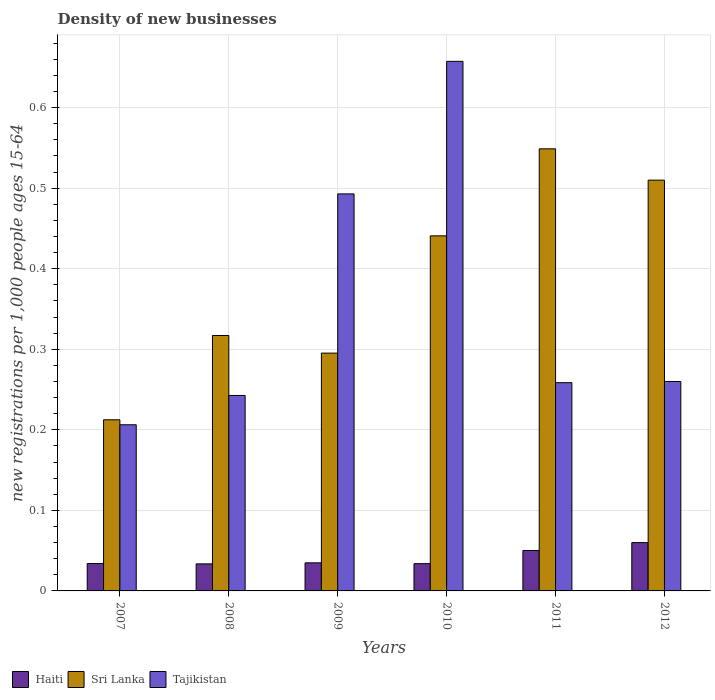Are the number of bars per tick equal to the number of legend labels?
Offer a terse response. Yes. How many bars are there on the 1st tick from the left?
Provide a short and direct response. 3. How many bars are there on the 5th tick from the right?
Offer a very short reply. 3. What is the label of the 2nd group of bars from the left?
Your answer should be compact. 2008. In how many cases, is the number of bars for a given year not equal to the number of legend labels?
Your answer should be very brief. 0. What is the number of new registrations in Sri Lanka in 2012?
Make the answer very short. 0.51. Across all years, what is the maximum number of new registrations in Sri Lanka?
Your response must be concise. 0.55. Across all years, what is the minimum number of new registrations in Haiti?
Provide a short and direct response. 0.03. What is the total number of new registrations in Tajikistan in the graph?
Make the answer very short. 2.12. What is the difference between the number of new registrations in Haiti in 2009 and that in 2011?
Your answer should be very brief. -0.02. What is the difference between the number of new registrations in Tajikistan in 2010 and the number of new registrations in Sri Lanka in 2009?
Provide a succinct answer. 0.36. What is the average number of new registrations in Haiti per year?
Give a very brief answer. 0.04. In the year 2008, what is the difference between the number of new registrations in Sri Lanka and number of new registrations in Tajikistan?
Provide a succinct answer. 0.07. What is the ratio of the number of new registrations in Tajikistan in 2008 to that in 2009?
Provide a succinct answer. 0.49. Is the difference between the number of new registrations in Sri Lanka in 2009 and 2012 greater than the difference between the number of new registrations in Tajikistan in 2009 and 2012?
Keep it short and to the point. No. What is the difference between the highest and the second highest number of new registrations in Tajikistan?
Your answer should be compact. 0.16. What is the difference between the highest and the lowest number of new registrations in Haiti?
Provide a short and direct response. 0.03. Is the sum of the number of new registrations in Haiti in 2009 and 2011 greater than the maximum number of new registrations in Tajikistan across all years?
Your answer should be very brief. No. What does the 2nd bar from the left in 2011 represents?
Ensure brevity in your answer.  Sri Lanka. What does the 1st bar from the right in 2010 represents?
Your answer should be compact. Tajikistan. Is it the case that in every year, the sum of the number of new registrations in Sri Lanka and number of new registrations in Haiti is greater than the number of new registrations in Tajikistan?
Provide a succinct answer. No. Are all the bars in the graph horizontal?
Give a very brief answer. No. What is the difference between two consecutive major ticks on the Y-axis?
Offer a terse response. 0.1. Does the graph contain any zero values?
Keep it short and to the point. No. How many legend labels are there?
Offer a very short reply. 3. What is the title of the graph?
Keep it short and to the point. Density of new businesses. What is the label or title of the Y-axis?
Make the answer very short. New registrations per 1,0 people ages 15-64. What is the new registrations per 1,000 people ages 15-64 of Haiti in 2007?
Keep it short and to the point. 0.03. What is the new registrations per 1,000 people ages 15-64 of Sri Lanka in 2007?
Provide a short and direct response. 0.21. What is the new registrations per 1,000 people ages 15-64 in Tajikistan in 2007?
Your answer should be compact. 0.21. What is the new registrations per 1,000 people ages 15-64 in Haiti in 2008?
Ensure brevity in your answer.  0.03. What is the new registrations per 1,000 people ages 15-64 in Sri Lanka in 2008?
Keep it short and to the point. 0.32. What is the new registrations per 1,000 people ages 15-64 in Tajikistan in 2008?
Offer a very short reply. 0.24. What is the new registrations per 1,000 people ages 15-64 in Haiti in 2009?
Give a very brief answer. 0.03. What is the new registrations per 1,000 people ages 15-64 in Sri Lanka in 2009?
Keep it short and to the point. 0.3. What is the new registrations per 1,000 people ages 15-64 in Tajikistan in 2009?
Provide a short and direct response. 0.49. What is the new registrations per 1,000 people ages 15-64 of Haiti in 2010?
Provide a short and direct response. 0.03. What is the new registrations per 1,000 people ages 15-64 in Sri Lanka in 2010?
Offer a very short reply. 0.44. What is the new registrations per 1,000 people ages 15-64 of Tajikistan in 2010?
Offer a terse response. 0.66. What is the new registrations per 1,000 people ages 15-64 of Haiti in 2011?
Offer a terse response. 0.05. What is the new registrations per 1,000 people ages 15-64 of Sri Lanka in 2011?
Offer a terse response. 0.55. What is the new registrations per 1,000 people ages 15-64 of Tajikistan in 2011?
Your response must be concise. 0.26. What is the new registrations per 1,000 people ages 15-64 of Haiti in 2012?
Offer a terse response. 0.06. What is the new registrations per 1,000 people ages 15-64 in Sri Lanka in 2012?
Your answer should be very brief. 0.51. What is the new registrations per 1,000 people ages 15-64 of Tajikistan in 2012?
Offer a very short reply. 0.26. Across all years, what is the maximum new registrations per 1,000 people ages 15-64 in Sri Lanka?
Offer a terse response. 0.55. Across all years, what is the maximum new registrations per 1,000 people ages 15-64 in Tajikistan?
Your answer should be very brief. 0.66. Across all years, what is the minimum new registrations per 1,000 people ages 15-64 in Haiti?
Your answer should be very brief. 0.03. Across all years, what is the minimum new registrations per 1,000 people ages 15-64 in Sri Lanka?
Your answer should be compact. 0.21. Across all years, what is the minimum new registrations per 1,000 people ages 15-64 in Tajikistan?
Provide a succinct answer. 0.21. What is the total new registrations per 1,000 people ages 15-64 in Haiti in the graph?
Ensure brevity in your answer.  0.25. What is the total new registrations per 1,000 people ages 15-64 of Sri Lanka in the graph?
Make the answer very short. 2.32. What is the total new registrations per 1,000 people ages 15-64 of Tajikistan in the graph?
Your answer should be very brief. 2.12. What is the difference between the new registrations per 1,000 people ages 15-64 in Haiti in 2007 and that in 2008?
Offer a terse response. 0. What is the difference between the new registrations per 1,000 people ages 15-64 in Sri Lanka in 2007 and that in 2008?
Provide a succinct answer. -0.1. What is the difference between the new registrations per 1,000 people ages 15-64 in Tajikistan in 2007 and that in 2008?
Provide a short and direct response. -0.04. What is the difference between the new registrations per 1,000 people ages 15-64 of Haiti in 2007 and that in 2009?
Offer a terse response. -0. What is the difference between the new registrations per 1,000 people ages 15-64 of Sri Lanka in 2007 and that in 2009?
Keep it short and to the point. -0.08. What is the difference between the new registrations per 1,000 people ages 15-64 of Tajikistan in 2007 and that in 2009?
Offer a very short reply. -0.29. What is the difference between the new registrations per 1,000 people ages 15-64 of Haiti in 2007 and that in 2010?
Your answer should be compact. 0. What is the difference between the new registrations per 1,000 people ages 15-64 of Sri Lanka in 2007 and that in 2010?
Offer a very short reply. -0.23. What is the difference between the new registrations per 1,000 people ages 15-64 of Tajikistan in 2007 and that in 2010?
Give a very brief answer. -0.45. What is the difference between the new registrations per 1,000 people ages 15-64 of Haiti in 2007 and that in 2011?
Provide a succinct answer. -0.02. What is the difference between the new registrations per 1,000 people ages 15-64 in Sri Lanka in 2007 and that in 2011?
Your answer should be very brief. -0.34. What is the difference between the new registrations per 1,000 people ages 15-64 in Tajikistan in 2007 and that in 2011?
Your answer should be very brief. -0.05. What is the difference between the new registrations per 1,000 people ages 15-64 in Haiti in 2007 and that in 2012?
Provide a succinct answer. -0.03. What is the difference between the new registrations per 1,000 people ages 15-64 in Sri Lanka in 2007 and that in 2012?
Your answer should be compact. -0.3. What is the difference between the new registrations per 1,000 people ages 15-64 of Tajikistan in 2007 and that in 2012?
Provide a short and direct response. -0.05. What is the difference between the new registrations per 1,000 people ages 15-64 in Haiti in 2008 and that in 2009?
Your response must be concise. -0. What is the difference between the new registrations per 1,000 people ages 15-64 of Sri Lanka in 2008 and that in 2009?
Make the answer very short. 0.02. What is the difference between the new registrations per 1,000 people ages 15-64 of Tajikistan in 2008 and that in 2009?
Make the answer very short. -0.25. What is the difference between the new registrations per 1,000 people ages 15-64 in Haiti in 2008 and that in 2010?
Offer a terse response. -0. What is the difference between the new registrations per 1,000 people ages 15-64 of Sri Lanka in 2008 and that in 2010?
Your answer should be very brief. -0.12. What is the difference between the new registrations per 1,000 people ages 15-64 in Tajikistan in 2008 and that in 2010?
Offer a very short reply. -0.41. What is the difference between the new registrations per 1,000 people ages 15-64 of Haiti in 2008 and that in 2011?
Make the answer very short. -0.02. What is the difference between the new registrations per 1,000 people ages 15-64 of Sri Lanka in 2008 and that in 2011?
Provide a succinct answer. -0.23. What is the difference between the new registrations per 1,000 people ages 15-64 in Tajikistan in 2008 and that in 2011?
Your response must be concise. -0.02. What is the difference between the new registrations per 1,000 people ages 15-64 in Haiti in 2008 and that in 2012?
Provide a succinct answer. -0.03. What is the difference between the new registrations per 1,000 people ages 15-64 in Sri Lanka in 2008 and that in 2012?
Offer a terse response. -0.19. What is the difference between the new registrations per 1,000 people ages 15-64 of Tajikistan in 2008 and that in 2012?
Your answer should be very brief. -0.02. What is the difference between the new registrations per 1,000 people ages 15-64 of Haiti in 2009 and that in 2010?
Your answer should be very brief. 0. What is the difference between the new registrations per 1,000 people ages 15-64 in Sri Lanka in 2009 and that in 2010?
Provide a succinct answer. -0.15. What is the difference between the new registrations per 1,000 people ages 15-64 in Tajikistan in 2009 and that in 2010?
Your answer should be compact. -0.16. What is the difference between the new registrations per 1,000 people ages 15-64 in Haiti in 2009 and that in 2011?
Your answer should be very brief. -0.02. What is the difference between the new registrations per 1,000 people ages 15-64 in Sri Lanka in 2009 and that in 2011?
Your response must be concise. -0.25. What is the difference between the new registrations per 1,000 people ages 15-64 in Tajikistan in 2009 and that in 2011?
Your answer should be compact. 0.23. What is the difference between the new registrations per 1,000 people ages 15-64 in Haiti in 2009 and that in 2012?
Offer a very short reply. -0.03. What is the difference between the new registrations per 1,000 people ages 15-64 in Sri Lanka in 2009 and that in 2012?
Ensure brevity in your answer.  -0.21. What is the difference between the new registrations per 1,000 people ages 15-64 in Tajikistan in 2009 and that in 2012?
Make the answer very short. 0.23. What is the difference between the new registrations per 1,000 people ages 15-64 in Haiti in 2010 and that in 2011?
Ensure brevity in your answer.  -0.02. What is the difference between the new registrations per 1,000 people ages 15-64 in Sri Lanka in 2010 and that in 2011?
Provide a short and direct response. -0.11. What is the difference between the new registrations per 1,000 people ages 15-64 in Tajikistan in 2010 and that in 2011?
Make the answer very short. 0.4. What is the difference between the new registrations per 1,000 people ages 15-64 of Haiti in 2010 and that in 2012?
Provide a short and direct response. -0.03. What is the difference between the new registrations per 1,000 people ages 15-64 of Sri Lanka in 2010 and that in 2012?
Make the answer very short. -0.07. What is the difference between the new registrations per 1,000 people ages 15-64 in Tajikistan in 2010 and that in 2012?
Offer a terse response. 0.4. What is the difference between the new registrations per 1,000 people ages 15-64 of Haiti in 2011 and that in 2012?
Provide a succinct answer. -0.01. What is the difference between the new registrations per 1,000 people ages 15-64 in Sri Lanka in 2011 and that in 2012?
Offer a very short reply. 0.04. What is the difference between the new registrations per 1,000 people ages 15-64 of Tajikistan in 2011 and that in 2012?
Provide a succinct answer. -0. What is the difference between the new registrations per 1,000 people ages 15-64 of Haiti in 2007 and the new registrations per 1,000 people ages 15-64 of Sri Lanka in 2008?
Give a very brief answer. -0.28. What is the difference between the new registrations per 1,000 people ages 15-64 in Haiti in 2007 and the new registrations per 1,000 people ages 15-64 in Tajikistan in 2008?
Ensure brevity in your answer.  -0.21. What is the difference between the new registrations per 1,000 people ages 15-64 in Sri Lanka in 2007 and the new registrations per 1,000 people ages 15-64 in Tajikistan in 2008?
Provide a succinct answer. -0.03. What is the difference between the new registrations per 1,000 people ages 15-64 of Haiti in 2007 and the new registrations per 1,000 people ages 15-64 of Sri Lanka in 2009?
Provide a short and direct response. -0.26. What is the difference between the new registrations per 1,000 people ages 15-64 in Haiti in 2007 and the new registrations per 1,000 people ages 15-64 in Tajikistan in 2009?
Your answer should be compact. -0.46. What is the difference between the new registrations per 1,000 people ages 15-64 in Sri Lanka in 2007 and the new registrations per 1,000 people ages 15-64 in Tajikistan in 2009?
Make the answer very short. -0.28. What is the difference between the new registrations per 1,000 people ages 15-64 of Haiti in 2007 and the new registrations per 1,000 people ages 15-64 of Sri Lanka in 2010?
Provide a succinct answer. -0.41. What is the difference between the new registrations per 1,000 people ages 15-64 in Haiti in 2007 and the new registrations per 1,000 people ages 15-64 in Tajikistan in 2010?
Your answer should be compact. -0.62. What is the difference between the new registrations per 1,000 people ages 15-64 in Sri Lanka in 2007 and the new registrations per 1,000 people ages 15-64 in Tajikistan in 2010?
Make the answer very short. -0.45. What is the difference between the new registrations per 1,000 people ages 15-64 in Haiti in 2007 and the new registrations per 1,000 people ages 15-64 in Sri Lanka in 2011?
Ensure brevity in your answer.  -0.51. What is the difference between the new registrations per 1,000 people ages 15-64 of Haiti in 2007 and the new registrations per 1,000 people ages 15-64 of Tajikistan in 2011?
Provide a succinct answer. -0.22. What is the difference between the new registrations per 1,000 people ages 15-64 in Sri Lanka in 2007 and the new registrations per 1,000 people ages 15-64 in Tajikistan in 2011?
Ensure brevity in your answer.  -0.05. What is the difference between the new registrations per 1,000 people ages 15-64 in Haiti in 2007 and the new registrations per 1,000 people ages 15-64 in Sri Lanka in 2012?
Give a very brief answer. -0.48. What is the difference between the new registrations per 1,000 people ages 15-64 in Haiti in 2007 and the new registrations per 1,000 people ages 15-64 in Tajikistan in 2012?
Offer a very short reply. -0.23. What is the difference between the new registrations per 1,000 people ages 15-64 of Sri Lanka in 2007 and the new registrations per 1,000 people ages 15-64 of Tajikistan in 2012?
Keep it short and to the point. -0.05. What is the difference between the new registrations per 1,000 people ages 15-64 of Haiti in 2008 and the new registrations per 1,000 people ages 15-64 of Sri Lanka in 2009?
Make the answer very short. -0.26. What is the difference between the new registrations per 1,000 people ages 15-64 of Haiti in 2008 and the new registrations per 1,000 people ages 15-64 of Tajikistan in 2009?
Your response must be concise. -0.46. What is the difference between the new registrations per 1,000 people ages 15-64 of Sri Lanka in 2008 and the new registrations per 1,000 people ages 15-64 of Tajikistan in 2009?
Ensure brevity in your answer.  -0.18. What is the difference between the new registrations per 1,000 people ages 15-64 in Haiti in 2008 and the new registrations per 1,000 people ages 15-64 in Sri Lanka in 2010?
Keep it short and to the point. -0.41. What is the difference between the new registrations per 1,000 people ages 15-64 in Haiti in 2008 and the new registrations per 1,000 people ages 15-64 in Tajikistan in 2010?
Ensure brevity in your answer.  -0.62. What is the difference between the new registrations per 1,000 people ages 15-64 of Sri Lanka in 2008 and the new registrations per 1,000 people ages 15-64 of Tajikistan in 2010?
Your response must be concise. -0.34. What is the difference between the new registrations per 1,000 people ages 15-64 in Haiti in 2008 and the new registrations per 1,000 people ages 15-64 in Sri Lanka in 2011?
Ensure brevity in your answer.  -0.52. What is the difference between the new registrations per 1,000 people ages 15-64 of Haiti in 2008 and the new registrations per 1,000 people ages 15-64 of Tajikistan in 2011?
Offer a terse response. -0.23. What is the difference between the new registrations per 1,000 people ages 15-64 in Sri Lanka in 2008 and the new registrations per 1,000 people ages 15-64 in Tajikistan in 2011?
Ensure brevity in your answer.  0.06. What is the difference between the new registrations per 1,000 people ages 15-64 in Haiti in 2008 and the new registrations per 1,000 people ages 15-64 in Sri Lanka in 2012?
Make the answer very short. -0.48. What is the difference between the new registrations per 1,000 people ages 15-64 of Haiti in 2008 and the new registrations per 1,000 people ages 15-64 of Tajikistan in 2012?
Make the answer very short. -0.23. What is the difference between the new registrations per 1,000 people ages 15-64 in Sri Lanka in 2008 and the new registrations per 1,000 people ages 15-64 in Tajikistan in 2012?
Offer a very short reply. 0.06. What is the difference between the new registrations per 1,000 people ages 15-64 in Haiti in 2009 and the new registrations per 1,000 people ages 15-64 in Sri Lanka in 2010?
Your answer should be very brief. -0.41. What is the difference between the new registrations per 1,000 people ages 15-64 in Haiti in 2009 and the new registrations per 1,000 people ages 15-64 in Tajikistan in 2010?
Your answer should be very brief. -0.62. What is the difference between the new registrations per 1,000 people ages 15-64 in Sri Lanka in 2009 and the new registrations per 1,000 people ages 15-64 in Tajikistan in 2010?
Give a very brief answer. -0.36. What is the difference between the new registrations per 1,000 people ages 15-64 in Haiti in 2009 and the new registrations per 1,000 people ages 15-64 in Sri Lanka in 2011?
Keep it short and to the point. -0.51. What is the difference between the new registrations per 1,000 people ages 15-64 in Haiti in 2009 and the new registrations per 1,000 people ages 15-64 in Tajikistan in 2011?
Make the answer very short. -0.22. What is the difference between the new registrations per 1,000 people ages 15-64 of Sri Lanka in 2009 and the new registrations per 1,000 people ages 15-64 of Tajikistan in 2011?
Your answer should be very brief. 0.04. What is the difference between the new registrations per 1,000 people ages 15-64 of Haiti in 2009 and the new registrations per 1,000 people ages 15-64 of Sri Lanka in 2012?
Keep it short and to the point. -0.48. What is the difference between the new registrations per 1,000 people ages 15-64 of Haiti in 2009 and the new registrations per 1,000 people ages 15-64 of Tajikistan in 2012?
Keep it short and to the point. -0.23. What is the difference between the new registrations per 1,000 people ages 15-64 of Sri Lanka in 2009 and the new registrations per 1,000 people ages 15-64 of Tajikistan in 2012?
Offer a very short reply. 0.04. What is the difference between the new registrations per 1,000 people ages 15-64 in Haiti in 2010 and the new registrations per 1,000 people ages 15-64 in Sri Lanka in 2011?
Ensure brevity in your answer.  -0.52. What is the difference between the new registrations per 1,000 people ages 15-64 in Haiti in 2010 and the new registrations per 1,000 people ages 15-64 in Tajikistan in 2011?
Offer a terse response. -0.22. What is the difference between the new registrations per 1,000 people ages 15-64 of Sri Lanka in 2010 and the new registrations per 1,000 people ages 15-64 of Tajikistan in 2011?
Ensure brevity in your answer.  0.18. What is the difference between the new registrations per 1,000 people ages 15-64 in Haiti in 2010 and the new registrations per 1,000 people ages 15-64 in Sri Lanka in 2012?
Offer a very short reply. -0.48. What is the difference between the new registrations per 1,000 people ages 15-64 of Haiti in 2010 and the new registrations per 1,000 people ages 15-64 of Tajikistan in 2012?
Ensure brevity in your answer.  -0.23. What is the difference between the new registrations per 1,000 people ages 15-64 in Sri Lanka in 2010 and the new registrations per 1,000 people ages 15-64 in Tajikistan in 2012?
Your answer should be very brief. 0.18. What is the difference between the new registrations per 1,000 people ages 15-64 in Haiti in 2011 and the new registrations per 1,000 people ages 15-64 in Sri Lanka in 2012?
Keep it short and to the point. -0.46. What is the difference between the new registrations per 1,000 people ages 15-64 in Haiti in 2011 and the new registrations per 1,000 people ages 15-64 in Tajikistan in 2012?
Keep it short and to the point. -0.21. What is the difference between the new registrations per 1,000 people ages 15-64 in Sri Lanka in 2011 and the new registrations per 1,000 people ages 15-64 in Tajikistan in 2012?
Your response must be concise. 0.29. What is the average new registrations per 1,000 people ages 15-64 of Haiti per year?
Your response must be concise. 0.04. What is the average new registrations per 1,000 people ages 15-64 in Sri Lanka per year?
Your answer should be compact. 0.39. What is the average new registrations per 1,000 people ages 15-64 of Tajikistan per year?
Your answer should be compact. 0.35. In the year 2007, what is the difference between the new registrations per 1,000 people ages 15-64 of Haiti and new registrations per 1,000 people ages 15-64 of Sri Lanka?
Your answer should be very brief. -0.18. In the year 2007, what is the difference between the new registrations per 1,000 people ages 15-64 of Haiti and new registrations per 1,000 people ages 15-64 of Tajikistan?
Offer a terse response. -0.17. In the year 2007, what is the difference between the new registrations per 1,000 people ages 15-64 in Sri Lanka and new registrations per 1,000 people ages 15-64 in Tajikistan?
Provide a succinct answer. 0.01. In the year 2008, what is the difference between the new registrations per 1,000 people ages 15-64 of Haiti and new registrations per 1,000 people ages 15-64 of Sri Lanka?
Ensure brevity in your answer.  -0.28. In the year 2008, what is the difference between the new registrations per 1,000 people ages 15-64 in Haiti and new registrations per 1,000 people ages 15-64 in Tajikistan?
Give a very brief answer. -0.21. In the year 2008, what is the difference between the new registrations per 1,000 people ages 15-64 in Sri Lanka and new registrations per 1,000 people ages 15-64 in Tajikistan?
Offer a very short reply. 0.07. In the year 2009, what is the difference between the new registrations per 1,000 people ages 15-64 in Haiti and new registrations per 1,000 people ages 15-64 in Sri Lanka?
Your response must be concise. -0.26. In the year 2009, what is the difference between the new registrations per 1,000 people ages 15-64 in Haiti and new registrations per 1,000 people ages 15-64 in Tajikistan?
Provide a short and direct response. -0.46. In the year 2009, what is the difference between the new registrations per 1,000 people ages 15-64 in Sri Lanka and new registrations per 1,000 people ages 15-64 in Tajikistan?
Offer a terse response. -0.2. In the year 2010, what is the difference between the new registrations per 1,000 people ages 15-64 in Haiti and new registrations per 1,000 people ages 15-64 in Sri Lanka?
Offer a very short reply. -0.41. In the year 2010, what is the difference between the new registrations per 1,000 people ages 15-64 in Haiti and new registrations per 1,000 people ages 15-64 in Tajikistan?
Your response must be concise. -0.62. In the year 2010, what is the difference between the new registrations per 1,000 people ages 15-64 in Sri Lanka and new registrations per 1,000 people ages 15-64 in Tajikistan?
Your response must be concise. -0.22. In the year 2011, what is the difference between the new registrations per 1,000 people ages 15-64 of Haiti and new registrations per 1,000 people ages 15-64 of Sri Lanka?
Provide a succinct answer. -0.5. In the year 2011, what is the difference between the new registrations per 1,000 people ages 15-64 of Haiti and new registrations per 1,000 people ages 15-64 of Tajikistan?
Offer a very short reply. -0.21. In the year 2011, what is the difference between the new registrations per 1,000 people ages 15-64 in Sri Lanka and new registrations per 1,000 people ages 15-64 in Tajikistan?
Give a very brief answer. 0.29. In the year 2012, what is the difference between the new registrations per 1,000 people ages 15-64 in Haiti and new registrations per 1,000 people ages 15-64 in Sri Lanka?
Provide a short and direct response. -0.45. In the year 2012, what is the difference between the new registrations per 1,000 people ages 15-64 of Haiti and new registrations per 1,000 people ages 15-64 of Tajikistan?
Your answer should be compact. -0.2. In the year 2012, what is the difference between the new registrations per 1,000 people ages 15-64 of Sri Lanka and new registrations per 1,000 people ages 15-64 of Tajikistan?
Make the answer very short. 0.25. What is the ratio of the new registrations per 1,000 people ages 15-64 in Haiti in 2007 to that in 2008?
Your answer should be very brief. 1.01. What is the ratio of the new registrations per 1,000 people ages 15-64 in Sri Lanka in 2007 to that in 2008?
Ensure brevity in your answer.  0.67. What is the ratio of the new registrations per 1,000 people ages 15-64 of Tajikistan in 2007 to that in 2008?
Offer a very short reply. 0.85. What is the ratio of the new registrations per 1,000 people ages 15-64 of Haiti in 2007 to that in 2009?
Your response must be concise. 0.98. What is the ratio of the new registrations per 1,000 people ages 15-64 of Sri Lanka in 2007 to that in 2009?
Ensure brevity in your answer.  0.72. What is the ratio of the new registrations per 1,000 people ages 15-64 of Tajikistan in 2007 to that in 2009?
Offer a very short reply. 0.42. What is the ratio of the new registrations per 1,000 people ages 15-64 in Haiti in 2007 to that in 2010?
Provide a succinct answer. 1. What is the ratio of the new registrations per 1,000 people ages 15-64 of Sri Lanka in 2007 to that in 2010?
Your response must be concise. 0.48. What is the ratio of the new registrations per 1,000 people ages 15-64 of Tajikistan in 2007 to that in 2010?
Offer a terse response. 0.31. What is the ratio of the new registrations per 1,000 people ages 15-64 of Haiti in 2007 to that in 2011?
Ensure brevity in your answer.  0.68. What is the ratio of the new registrations per 1,000 people ages 15-64 in Sri Lanka in 2007 to that in 2011?
Your answer should be very brief. 0.39. What is the ratio of the new registrations per 1,000 people ages 15-64 of Tajikistan in 2007 to that in 2011?
Offer a terse response. 0.8. What is the ratio of the new registrations per 1,000 people ages 15-64 of Haiti in 2007 to that in 2012?
Offer a terse response. 0.57. What is the ratio of the new registrations per 1,000 people ages 15-64 of Sri Lanka in 2007 to that in 2012?
Offer a terse response. 0.42. What is the ratio of the new registrations per 1,000 people ages 15-64 of Tajikistan in 2007 to that in 2012?
Your answer should be very brief. 0.79. What is the ratio of the new registrations per 1,000 people ages 15-64 of Haiti in 2008 to that in 2009?
Your answer should be compact. 0.96. What is the ratio of the new registrations per 1,000 people ages 15-64 in Sri Lanka in 2008 to that in 2009?
Ensure brevity in your answer.  1.07. What is the ratio of the new registrations per 1,000 people ages 15-64 of Tajikistan in 2008 to that in 2009?
Your answer should be very brief. 0.49. What is the ratio of the new registrations per 1,000 people ages 15-64 in Sri Lanka in 2008 to that in 2010?
Provide a succinct answer. 0.72. What is the ratio of the new registrations per 1,000 people ages 15-64 of Tajikistan in 2008 to that in 2010?
Your answer should be compact. 0.37. What is the ratio of the new registrations per 1,000 people ages 15-64 in Haiti in 2008 to that in 2011?
Provide a succinct answer. 0.67. What is the ratio of the new registrations per 1,000 people ages 15-64 in Sri Lanka in 2008 to that in 2011?
Your response must be concise. 0.58. What is the ratio of the new registrations per 1,000 people ages 15-64 of Tajikistan in 2008 to that in 2011?
Your response must be concise. 0.94. What is the ratio of the new registrations per 1,000 people ages 15-64 of Haiti in 2008 to that in 2012?
Your answer should be very brief. 0.56. What is the ratio of the new registrations per 1,000 people ages 15-64 of Sri Lanka in 2008 to that in 2012?
Your response must be concise. 0.62. What is the ratio of the new registrations per 1,000 people ages 15-64 of Tajikistan in 2008 to that in 2012?
Offer a terse response. 0.93. What is the ratio of the new registrations per 1,000 people ages 15-64 in Haiti in 2009 to that in 2010?
Offer a terse response. 1.03. What is the ratio of the new registrations per 1,000 people ages 15-64 of Sri Lanka in 2009 to that in 2010?
Your answer should be compact. 0.67. What is the ratio of the new registrations per 1,000 people ages 15-64 of Tajikistan in 2009 to that in 2010?
Give a very brief answer. 0.75. What is the ratio of the new registrations per 1,000 people ages 15-64 in Haiti in 2009 to that in 2011?
Provide a short and direct response. 0.69. What is the ratio of the new registrations per 1,000 people ages 15-64 of Sri Lanka in 2009 to that in 2011?
Provide a short and direct response. 0.54. What is the ratio of the new registrations per 1,000 people ages 15-64 of Tajikistan in 2009 to that in 2011?
Provide a succinct answer. 1.91. What is the ratio of the new registrations per 1,000 people ages 15-64 of Haiti in 2009 to that in 2012?
Your response must be concise. 0.58. What is the ratio of the new registrations per 1,000 people ages 15-64 in Sri Lanka in 2009 to that in 2012?
Provide a succinct answer. 0.58. What is the ratio of the new registrations per 1,000 people ages 15-64 of Tajikistan in 2009 to that in 2012?
Keep it short and to the point. 1.9. What is the ratio of the new registrations per 1,000 people ages 15-64 in Haiti in 2010 to that in 2011?
Provide a short and direct response. 0.67. What is the ratio of the new registrations per 1,000 people ages 15-64 of Sri Lanka in 2010 to that in 2011?
Provide a succinct answer. 0.8. What is the ratio of the new registrations per 1,000 people ages 15-64 of Tajikistan in 2010 to that in 2011?
Keep it short and to the point. 2.54. What is the ratio of the new registrations per 1,000 people ages 15-64 of Haiti in 2010 to that in 2012?
Provide a short and direct response. 0.56. What is the ratio of the new registrations per 1,000 people ages 15-64 of Sri Lanka in 2010 to that in 2012?
Your response must be concise. 0.86. What is the ratio of the new registrations per 1,000 people ages 15-64 of Tajikistan in 2010 to that in 2012?
Provide a short and direct response. 2.53. What is the ratio of the new registrations per 1,000 people ages 15-64 of Haiti in 2011 to that in 2012?
Make the answer very short. 0.84. What is the ratio of the new registrations per 1,000 people ages 15-64 of Sri Lanka in 2011 to that in 2012?
Ensure brevity in your answer.  1.08. What is the ratio of the new registrations per 1,000 people ages 15-64 in Tajikistan in 2011 to that in 2012?
Make the answer very short. 0.99. What is the difference between the highest and the second highest new registrations per 1,000 people ages 15-64 of Haiti?
Your response must be concise. 0.01. What is the difference between the highest and the second highest new registrations per 1,000 people ages 15-64 in Sri Lanka?
Ensure brevity in your answer.  0.04. What is the difference between the highest and the second highest new registrations per 1,000 people ages 15-64 in Tajikistan?
Provide a succinct answer. 0.16. What is the difference between the highest and the lowest new registrations per 1,000 people ages 15-64 in Haiti?
Your answer should be compact. 0.03. What is the difference between the highest and the lowest new registrations per 1,000 people ages 15-64 in Sri Lanka?
Your answer should be compact. 0.34. What is the difference between the highest and the lowest new registrations per 1,000 people ages 15-64 in Tajikistan?
Give a very brief answer. 0.45. 